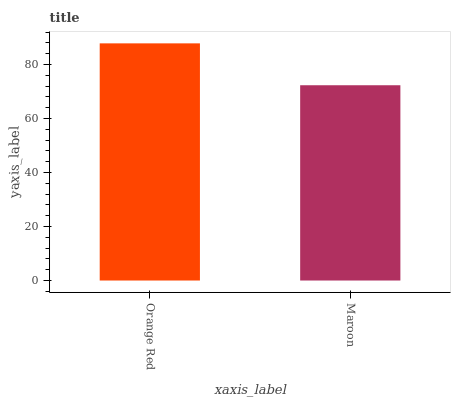Is Maroon the minimum?
Answer yes or no. Yes. Is Orange Red the maximum?
Answer yes or no. Yes. Is Maroon the maximum?
Answer yes or no. No. Is Orange Red greater than Maroon?
Answer yes or no. Yes. Is Maroon less than Orange Red?
Answer yes or no. Yes. Is Maroon greater than Orange Red?
Answer yes or no. No. Is Orange Red less than Maroon?
Answer yes or no. No. Is Orange Red the high median?
Answer yes or no. Yes. Is Maroon the low median?
Answer yes or no. Yes. Is Maroon the high median?
Answer yes or no. No. Is Orange Red the low median?
Answer yes or no. No. 